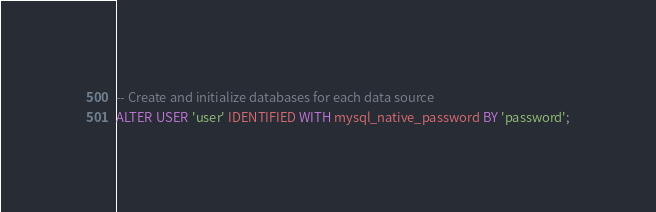<code> <loc_0><loc_0><loc_500><loc_500><_SQL_>-- Create and initialize databases for each data source
ALTER USER 'user' IDENTIFIED WITH mysql_native_password BY 'password';

</code> 